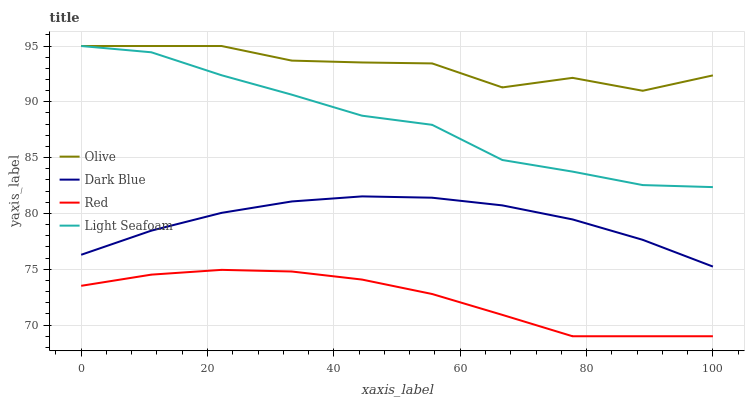Does Dark Blue have the minimum area under the curve?
Answer yes or no. No. Does Dark Blue have the maximum area under the curve?
Answer yes or no. No. Is Light Seafoam the smoothest?
Answer yes or no. No. Is Light Seafoam the roughest?
Answer yes or no. No. Does Dark Blue have the lowest value?
Answer yes or no. No. Does Dark Blue have the highest value?
Answer yes or no. No. Is Dark Blue less than Olive?
Answer yes or no. Yes. Is Olive greater than Dark Blue?
Answer yes or no. Yes. Does Dark Blue intersect Olive?
Answer yes or no. No. 